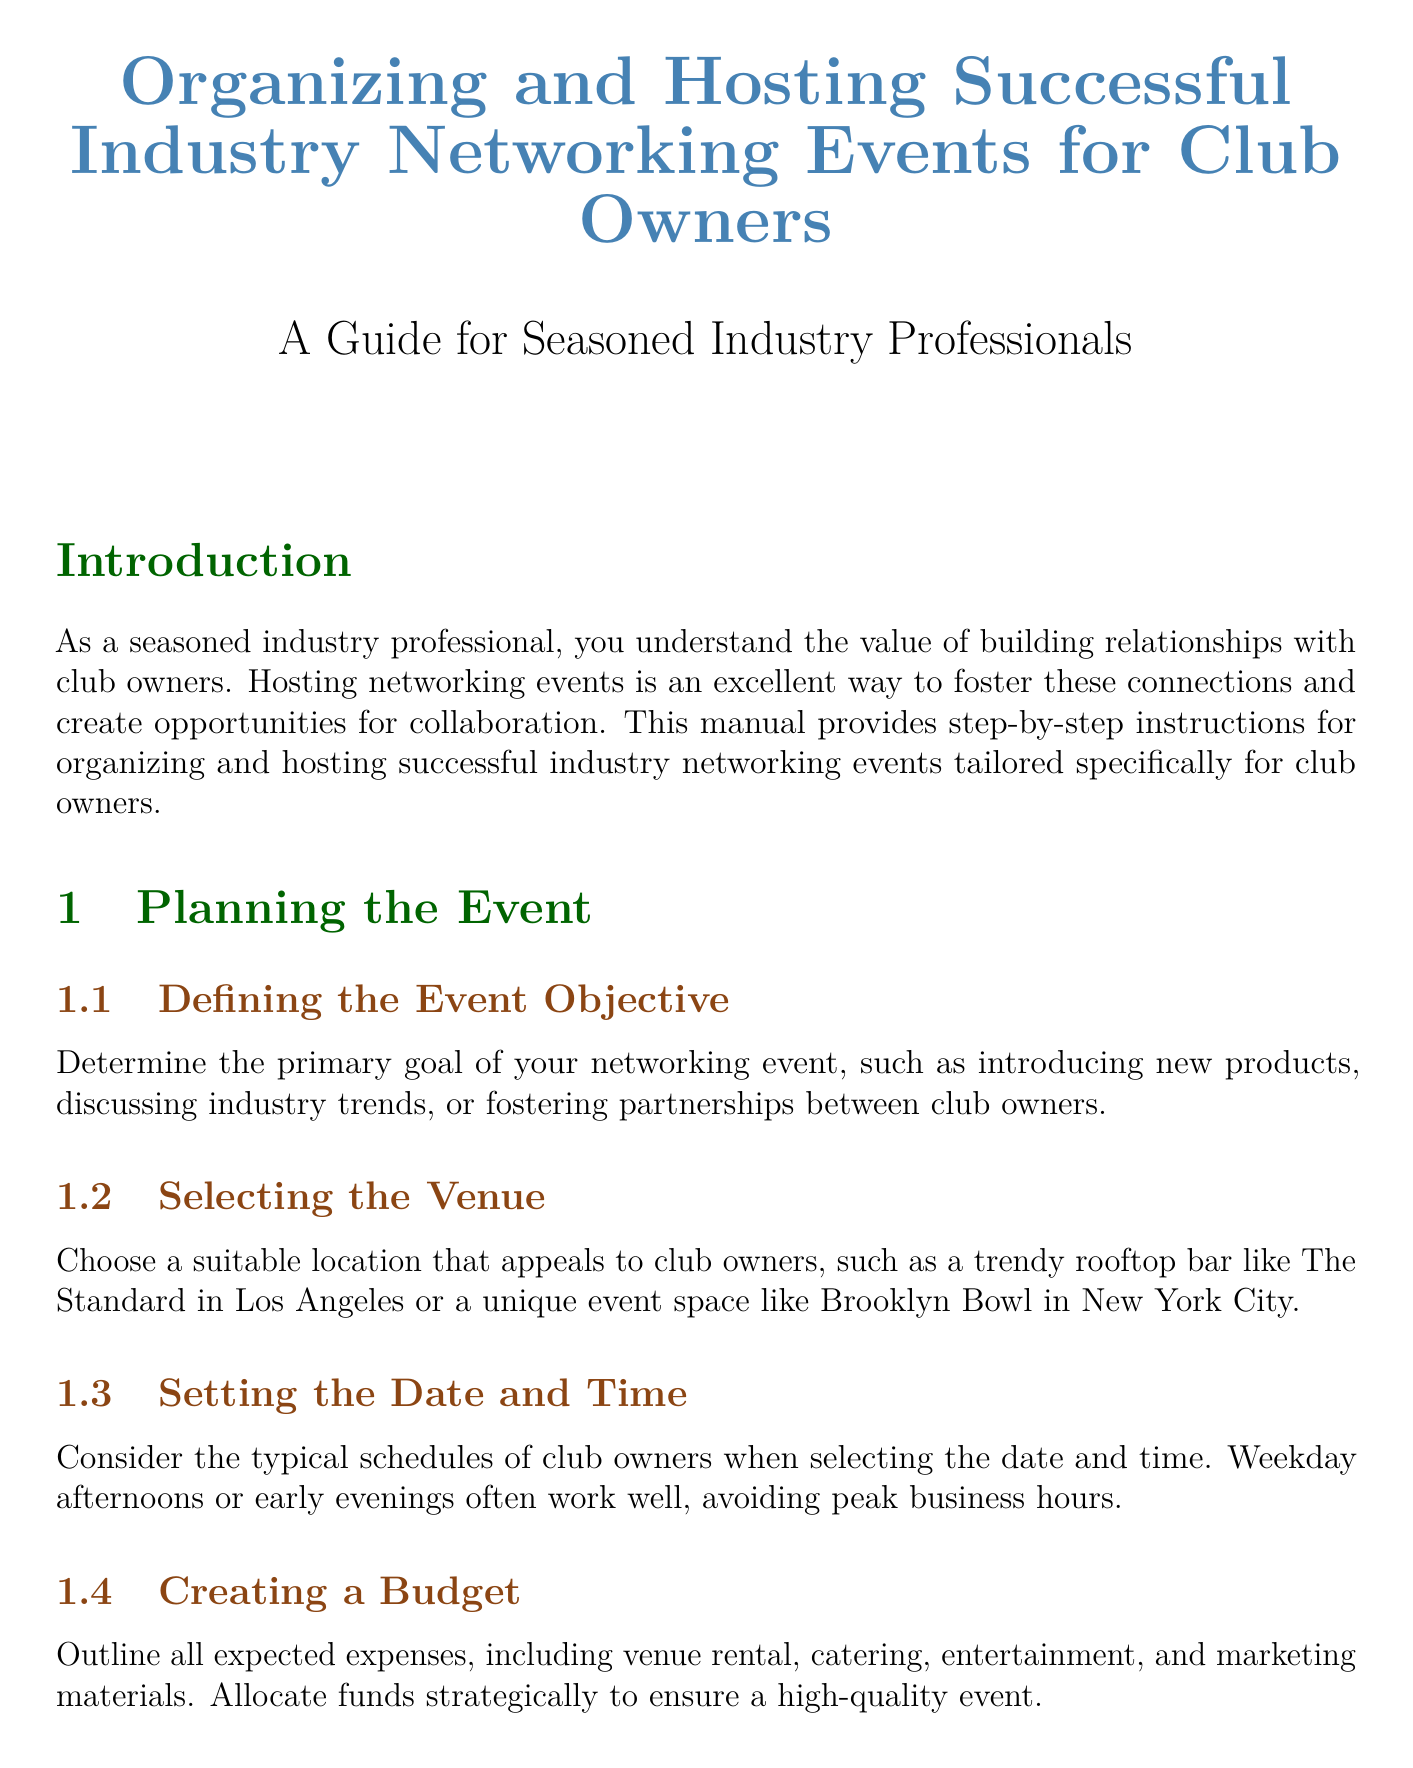What is the title of the manual? The title of the manual is clearly stated at the beginning and is "Organizing and Hosting Successful Industry Networking Events for Club Owners."
Answer: Organizing and Hosting Successful Industry Networking Events for Club Owners What is one example of a venue suggested for the event? The manual provides examples of suitable venues, including "The Standard in Los Angeles."
Answer: The Standard in Los Angeles What should be included in the name tags? The document specifies that name tags should include the attendee's name, club name, and a conversation starter.
Answer: Attendee's name, club name, and a conversation starter How long after the event should thank you notes be sent? The manual states that thank you emails should be sent "within 48 hours of the event."
Answer: Within 48 hours of the event What is one interactive element recommended for the event? The manual suggests incorporating activities such as "mixology demonstrations."
Answer: Mixology demonstrations What is the main objective of the manual? The manual's main purpose is to provide "step-by-step instructions for organizing and hosting successful industry networking events tailored specifically for club owners."
Answer: Step-by-step instructions for organizing and hosting successful industry networking events tailored specifically for club owners How should RSVPs be managed? The document recommends using an event management platform like "Eventbrite" to track responses.
Answer: Eventbrite Which section discusses identifying key attendees? The section titled "Identifying Key Attendees" addresses this topic specifically in the manual.
Answer: Identifying Key Attendees 